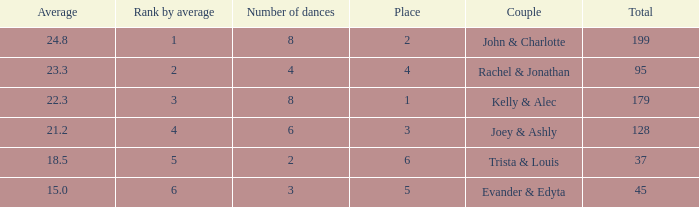What is the highest average that has 6 dances and a total of over 128? None. 